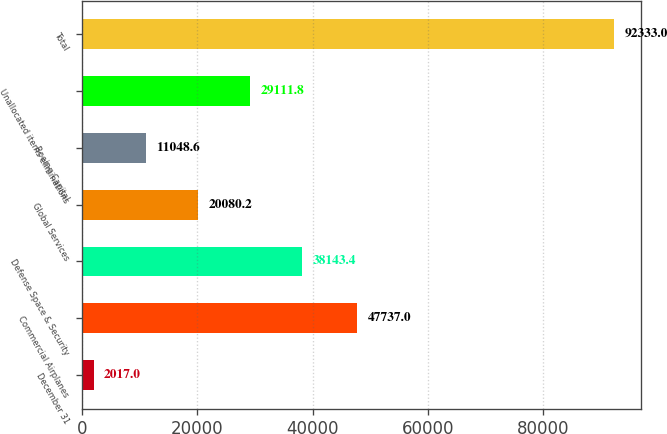Convert chart to OTSL. <chart><loc_0><loc_0><loc_500><loc_500><bar_chart><fcel>December 31<fcel>Commercial Airplanes<fcel>Defense Space & Security<fcel>Global Services<fcel>Boeing Capital<fcel>Unallocated items eliminations<fcel>Total<nl><fcel>2017<fcel>47737<fcel>38143.4<fcel>20080.2<fcel>11048.6<fcel>29111.8<fcel>92333<nl></chart> 